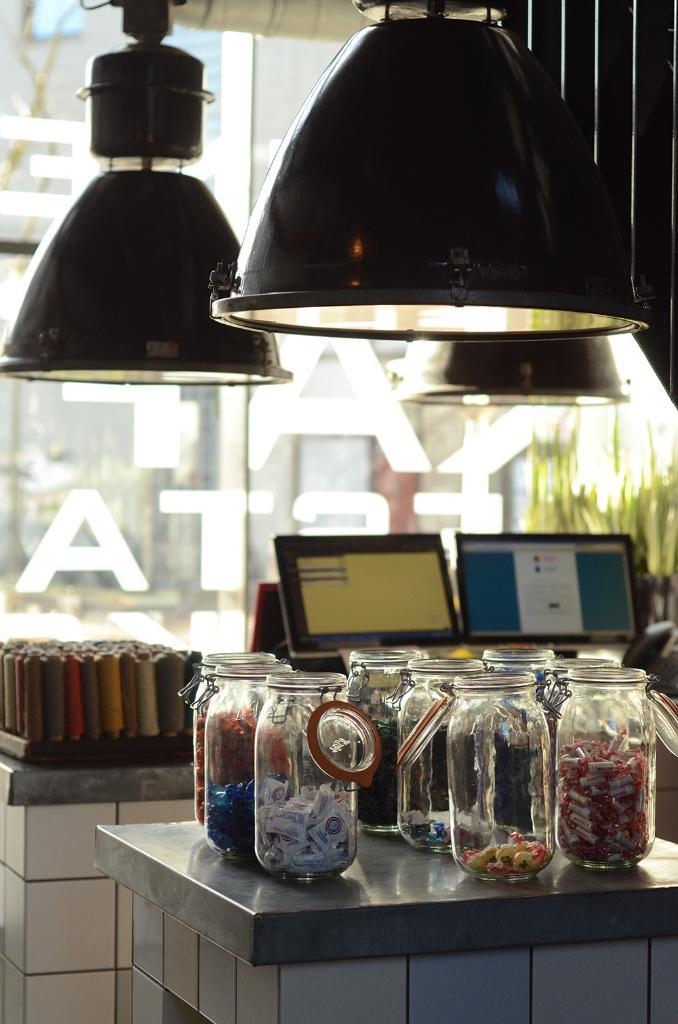What objects are placed on the table in the image? There are jars placed on the table in the image. What is inside the jars? The jars contain candies. What can be seen in the background of the image? There are two monitors in the background. What type of container is visible in the image? There is a glass in the image. How does the number of candies in the jars compare to the number of buildings downtown? There is no information about the number of candies in the jars or the number of buildings downtown, so it is impossible to make a comparison. 